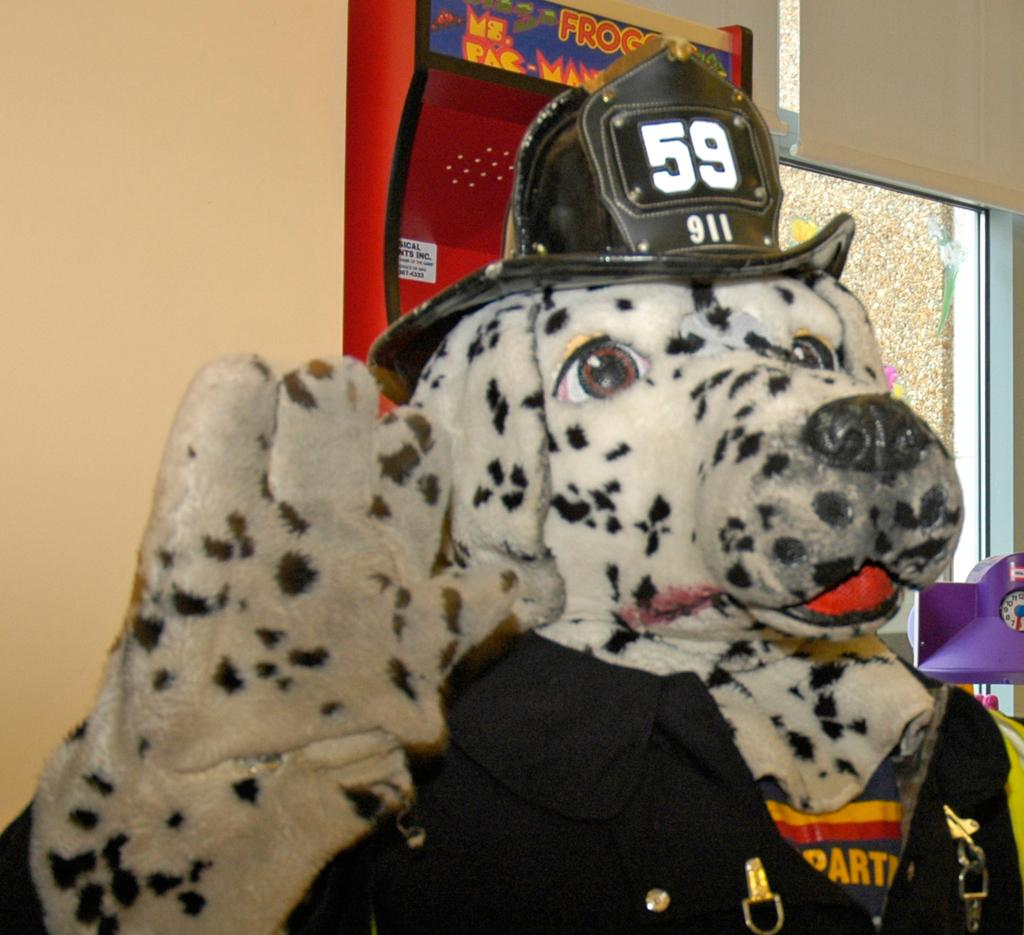What type of animal is present in the image? There is a dog in the image. What is the dog wearing? The dog is wearing a cap. What can be seen in the background of the image? There is a wall and a red object in the background of the image. What type of cake is being served under the arch in the image? There is no cake or arch present in the image; it features a dog wearing a cap with a wall and a red object in the background. 